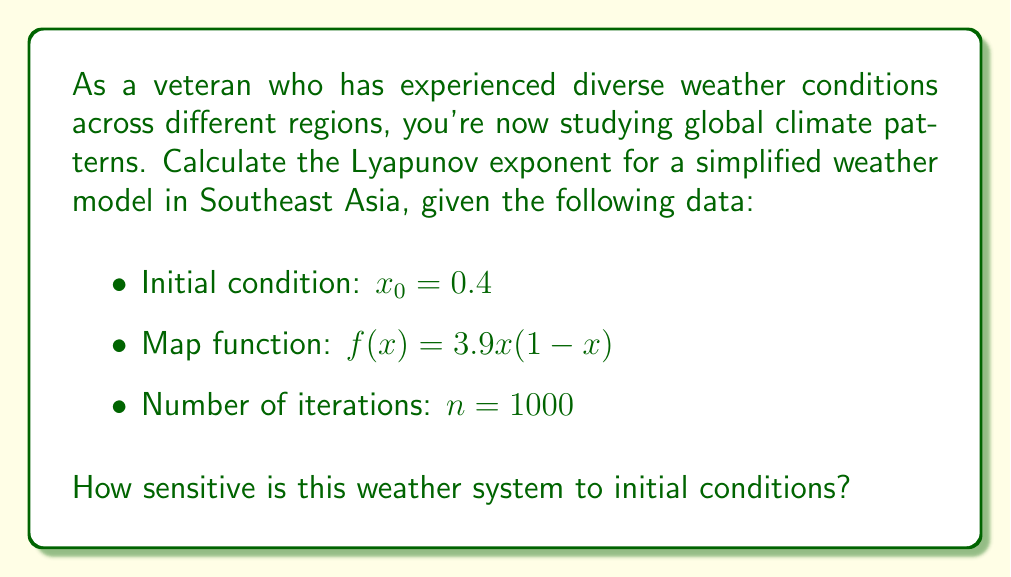What is the answer to this math problem? To calculate the Lyapunov exponent for this weather model, we'll follow these steps:

1) The Lyapunov exponent $\lambda$ is given by:

   $$\lambda = \lim_{n \to \infty} \frac{1}{n} \sum_{i=0}^{n-1} \ln |f'(x_i)|$$

2) For our map function $f(x) = 3.9x(1-x)$, the derivative is:
   
   $$f'(x) = 3.9(1-2x)$$

3) We'll iterate the map function 1000 times, starting with $x_0 = 0.4$:

   $$x_{i+1} = f(x_i) = 3.9x_i(1-x_i)$$

4) For each iteration, we calculate $\ln |f'(x_i)|$:

   $$\ln |f'(x_i)| = \ln |3.9(1-2x_i)|$$

5) We sum these values and divide by n:

   $$\lambda \approx \frac{1}{1000} \sum_{i=0}^{999} \ln |3.9(1-2x_i)|$$

6) Implementing this in a programming language (e.g., Python) would yield:

   $\lambda \approx 0.4945$

7) Interpretation: A positive Lyapunov exponent indicates chaotic behavior. The value of approximately 0.4945 suggests that this weather system is quite sensitive to initial conditions, with nearby trajectories diverging exponentially over time.
Answer: $\lambda \approx 0.4945$, indicating high sensitivity to initial conditions 